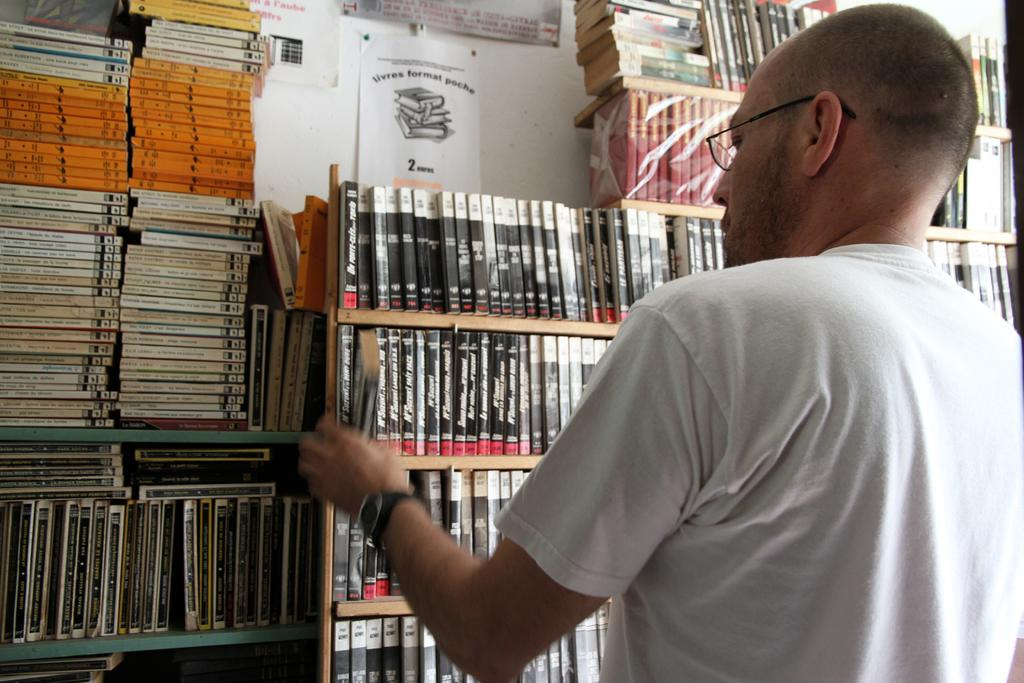<image>
Offer a succinct explanation of the picture presented. Livres format poche sign above a book shelf. 